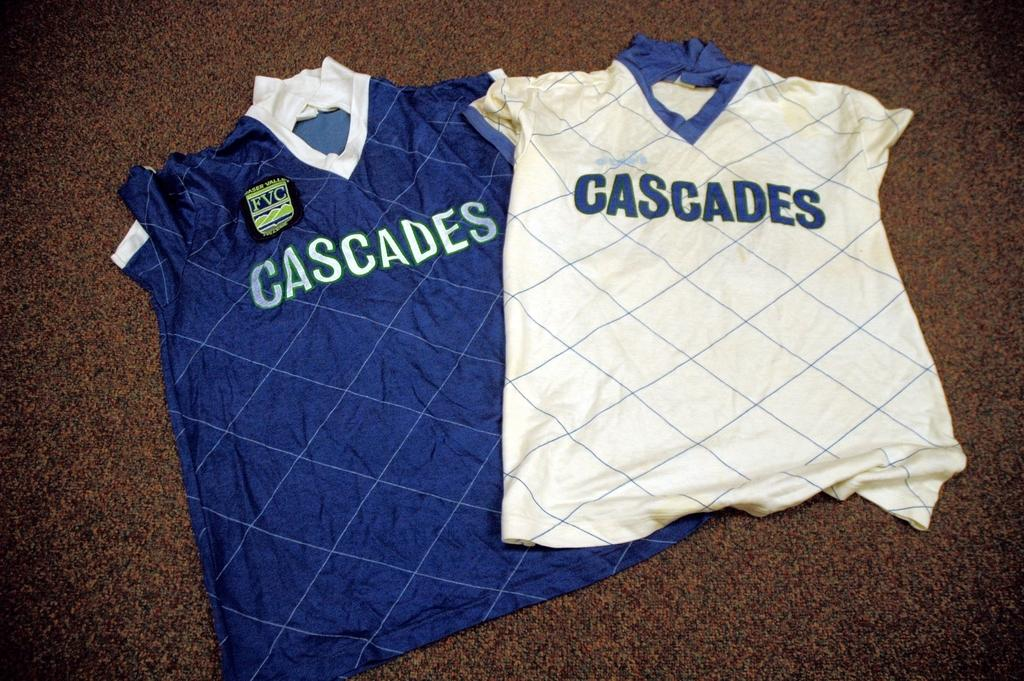Provide a one-sentence caption for the provided image. A white and blue shirt that say Cascades are on the floor next to each other. 